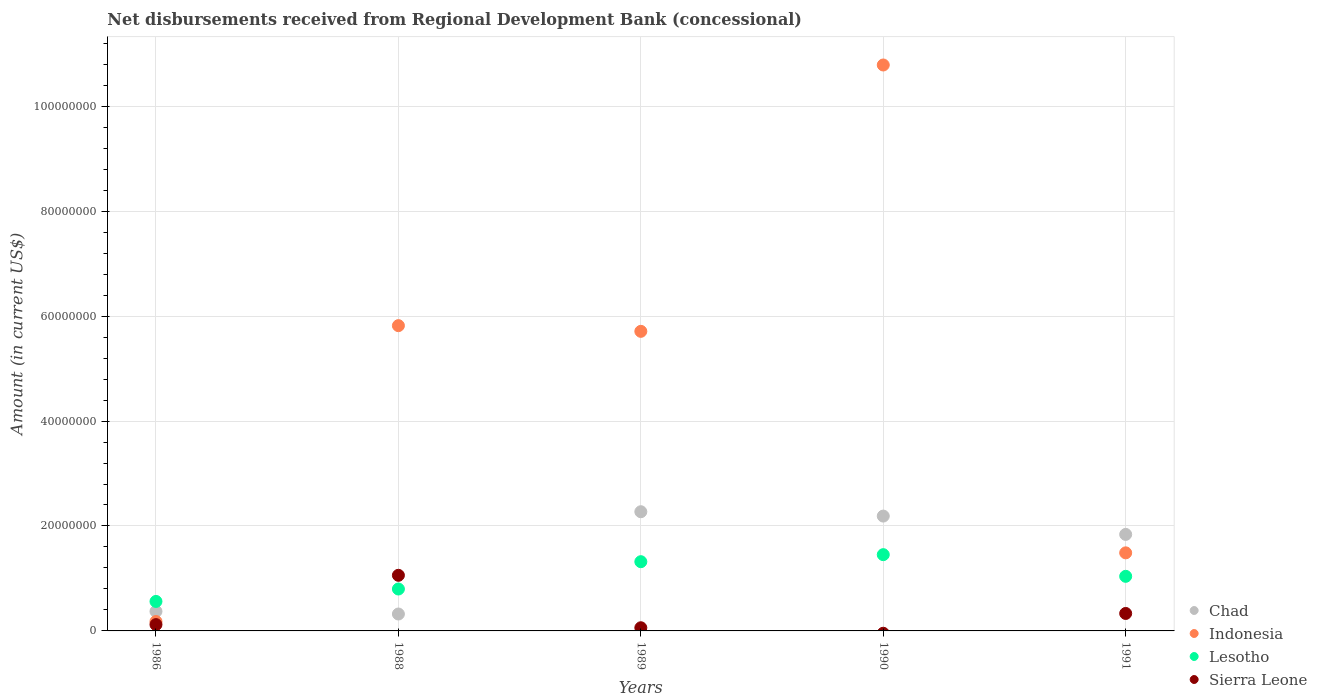What is the amount of disbursements received from Regional Development Bank in Chad in 1989?
Keep it short and to the point. 2.27e+07. Across all years, what is the maximum amount of disbursements received from Regional Development Bank in Sierra Leone?
Your answer should be compact. 1.06e+07. Across all years, what is the minimum amount of disbursements received from Regional Development Bank in Indonesia?
Give a very brief answer. 1.79e+06. In which year was the amount of disbursements received from Regional Development Bank in Sierra Leone maximum?
Your answer should be compact. 1988. What is the total amount of disbursements received from Regional Development Bank in Sierra Leone in the graph?
Your response must be concise. 1.57e+07. What is the difference between the amount of disbursements received from Regional Development Bank in Lesotho in 1986 and that in 1988?
Ensure brevity in your answer.  -2.37e+06. What is the difference between the amount of disbursements received from Regional Development Bank in Lesotho in 1991 and the amount of disbursements received from Regional Development Bank in Sierra Leone in 1989?
Your answer should be compact. 9.80e+06. What is the average amount of disbursements received from Regional Development Bank in Indonesia per year?
Keep it short and to the point. 4.80e+07. In the year 1986, what is the difference between the amount of disbursements received from Regional Development Bank in Indonesia and amount of disbursements received from Regional Development Bank in Sierra Leone?
Make the answer very short. 5.86e+05. What is the ratio of the amount of disbursements received from Regional Development Bank in Lesotho in 1986 to that in 1989?
Offer a terse response. 0.43. Is the amount of disbursements received from Regional Development Bank in Chad in 1988 less than that in 1991?
Your answer should be very brief. Yes. Is the difference between the amount of disbursements received from Regional Development Bank in Indonesia in 1986 and 1988 greater than the difference between the amount of disbursements received from Regional Development Bank in Sierra Leone in 1986 and 1988?
Provide a short and direct response. No. What is the difference between the highest and the second highest amount of disbursements received from Regional Development Bank in Indonesia?
Provide a succinct answer. 4.97e+07. What is the difference between the highest and the lowest amount of disbursements received from Regional Development Bank in Sierra Leone?
Make the answer very short. 1.06e+07. Is it the case that in every year, the sum of the amount of disbursements received from Regional Development Bank in Lesotho and amount of disbursements received from Regional Development Bank in Indonesia  is greater than the sum of amount of disbursements received from Regional Development Bank in Sierra Leone and amount of disbursements received from Regional Development Bank in Chad?
Give a very brief answer. No. Is the amount of disbursements received from Regional Development Bank in Lesotho strictly greater than the amount of disbursements received from Regional Development Bank in Chad over the years?
Your answer should be compact. No. How many dotlines are there?
Provide a short and direct response. 4. How many years are there in the graph?
Provide a succinct answer. 5. What is the difference between two consecutive major ticks on the Y-axis?
Provide a succinct answer. 2.00e+07. Does the graph contain any zero values?
Offer a very short reply. Yes. Does the graph contain grids?
Your response must be concise. Yes. Where does the legend appear in the graph?
Ensure brevity in your answer.  Bottom right. How many legend labels are there?
Your answer should be very brief. 4. How are the legend labels stacked?
Offer a terse response. Vertical. What is the title of the graph?
Your answer should be very brief. Net disbursements received from Regional Development Bank (concessional). Does "Jordan" appear as one of the legend labels in the graph?
Your answer should be very brief. No. What is the label or title of the X-axis?
Your response must be concise. Years. What is the label or title of the Y-axis?
Your answer should be compact. Amount (in current US$). What is the Amount (in current US$) in Chad in 1986?
Provide a short and direct response. 3.72e+06. What is the Amount (in current US$) of Indonesia in 1986?
Your answer should be compact. 1.79e+06. What is the Amount (in current US$) of Lesotho in 1986?
Make the answer very short. 5.62e+06. What is the Amount (in current US$) in Sierra Leone in 1986?
Offer a very short reply. 1.21e+06. What is the Amount (in current US$) in Chad in 1988?
Your answer should be very brief. 3.22e+06. What is the Amount (in current US$) of Indonesia in 1988?
Your answer should be very brief. 5.82e+07. What is the Amount (in current US$) in Lesotho in 1988?
Your response must be concise. 7.99e+06. What is the Amount (in current US$) of Sierra Leone in 1988?
Offer a terse response. 1.06e+07. What is the Amount (in current US$) of Chad in 1989?
Offer a terse response. 2.27e+07. What is the Amount (in current US$) in Indonesia in 1989?
Offer a very short reply. 5.71e+07. What is the Amount (in current US$) of Lesotho in 1989?
Provide a short and direct response. 1.32e+07. What is the Amount (in current US$) in Sierra Leone in 1989?
Your answer should be compact. 6.03e+05. What is the Amount (in current US$) of Chad in 1990?
Your response must be concise. 2.19e+07. What is the Amount (in current US$) of Indonesia in 1990?
Provide a succinct answer. 1.08e+08. What is the Amount (in current US$) of Lesotho in 1990?
Keep it short and to the point. 1.45e+07. What is the Amount (in current US$) in Chad in 1991?
Your response must be concise. 1.84e+07. What is the Amount (in current US$) in Indonesia in 1991?
Give a very brief answer. 1.49e+07. What is the Amount (in current US$) in Lesotho in 1991?
Your answer should be compact. 1.04e+07. What is the Amount (in current US$) of Sierra Leone in 1991?
Provide a short and direct response. 3.33e+06. Across all years, what is the maximum Amount (in current US$) in Chad?
Your answer should be very brief. 2.27e+07. Across all years, what is the maximum Amount (in current US$) in Indonesia?
Give a very brief answer. 1.08e+08. Across all years, what is the maximum Amount (in current US$) of Lesotho?
Your answer should be compact. 1.45e+07. Across all years, what is the maximum Amount (in current US$) in Sierra Leone?
Offer a terse response. 1.06e+07. Across all years, what is the minimum Amount (in current US$) in Chad?
Provide a short and direct response. 3.22e+06. Across all years, what is the minimum Amount (in current US$) in Indonesia?
Give a very brief answer. 1.79e+06. Across all years, what is the minimum Amount (in current US$) in Lesotho?
Give a very brief answer. 5.62e+06. Across all years, what is the minimum Amount (in current US$) in Sierra Leone?
Keep it short and to the point. 0. What is the total Amount (in current US$) in Chad in the graph?
Your response must be concise. 6.99e+07. What is the total Amount (in current US$) in Indonesia in the graph?
Your response must be concise. 2.40e+08. What is the total Amount (in current US$) in Lesotho in the graph?
Provide a short and direct response. 5.17e+07. What is the total Amount (in current US$) in Sierra Leone in the graph?
Ensure brevity in your answer.  1.57e+07. What is the difference between the Amount (in current US$) in Chad in 1986 and that in 1988?
Provide a short and direct response. 4.99e+05. What is the difference between the Amount (in current US$) in Indonesia in 1986 and that in 1988?
Offer a terse response. -5.64e+07. What is the difference between the Amount (in current US$) in Lesotho in 1986 and that in 1988?
Provide a succinct answer. -2.37e+06. What is the difference between the Amount (in current US$) in Sierra Leone in 1986 and that in 1988?
Your response must be concise. -9.39e+06. What is the difference between the Amount (in current US$) in Chad in 1986 and that in 1989?
Your answer should be compact. -1.90e+07. What is the difference between the Amount (in current US$) in Indonesia in 1986 and that in 1989?
Keep it short and to the point. -5.53e+07. What is the difference between the Amount (in current US$) in Lesotho in 1986 and that in 1989?
Provide a short and direct response. -7.57e+06. What is the difference between the Amount (in current US$) in Sierra Leone in 1986 and that in 1989?
Your answer should be very brief. 6.03e+05. What is the difference between the Amount (in current US$) in Chad in 1986 and that in 1990?
Provide a succinct answer. -1.82e+07. What is the difference between the Amount (in current US$) in Indonesia in 1986 and that in 1990?
Provide a succinct answer. -1.06e+08. What is the difference between the Amount (in current US$) in Lesotho in 1986 and that in 1990?
Give a very brief answer. -8.92e+06. What is the difference between the Amount (in current US$) of Chad in 1986 and that in 1991?
Provide a short and direct response. -1.47e+07. What is the difference between the Amount (in current US$) in Indonesia in 1986 and that in 1991?
Your answer should be very brief. -1.31e+07. What is the difference between the Amount (in current US$) in Lesotho in 1986 and that in 1991?
Provide a short and direct response. -4.78e+06. What is the difference between the Amount (in current US$) in Sierra Leone in 1986 and that in 1991?
Your answer should be compact. -2.12e+06. What is the difference between the Amount (in current US$) in Chad in 1988 and that in 1989?
Offer a terse response. -1.95e+07. What is the difference between the Amount (in current US$) in Indonesia in 1988 and that in 1989?
Ensure brevity in your answer.  1.08e+06. What is the difference between the Amount (in current US$) of Lesotho in 1988 and that in 1989?
Your answer should be compact. -5.20e+06. What is the difference between the Amount (in current US$) of Sierra Leone in 1988 and that in 1989?
Offer a very short reply. 1.00e+07. What is the difference between the Amount (in current US$) in Chad in 1988 and that in 1990?
Provide a succinct answer. -1.87e+07. What is the difference between the Amount (in current US$) in Indonesia in 1988 and that in 1990?
Offer a terse response. -4.97e+07. What is the difference between the Amount (in current US$) in Lesotho in 1988 and that in 1990?
Give a very brief answer. -6.55e+06. What is the difference between the Amount (in current US$) in Chad in 1988 and that in 1991?
Keep it short and to the point. -1.52e+07. What is the difference between the Amount (in current US$) of Indonesia in 1988 and that in 1991?
Offer a terse response. 4.33e+07. What is the difference between the Amount (in current US$) of Lesotho in 1988 and that in 1991?
Provide a succinct answer. -2.42e+06. What is the difference between the Amount (in current US$) of Sierra Leone in 1988 and that in 1991?
Your answer should be very brief. 7.27e+06. What is the difference between the Amount (in current US$) of Chad in 1989 and that in 1990?
Provide a succinct answer. 8.29e+05. What is the difference between the Amount (in current US$) of Indonesia in 1989 and that in 1990?
Make the answer very short. -5.08e+07. What is the difference between the Amount (in current US$) in Lesotho in 1989 and that in 1990?
Your response must be concise. -1.34e+06. What is the difference between the Amount (in current US$) of Chad in 1989 and that in 1991?
Provide a succinct answer. 4.32e+06. What is the difference between the Amount (in current US$) of Indonesia in 1989 and that in 1991?
Offer a terse response. 4.22e+07. What is the difference between the Amount (in current US$) in Lesotho in 1989 and that in 1991?
Make the answer very short. 2.79e+06. What is the difference between the Amount (in current US$) of Sierra Leone in 1989 and that in 1991?
Give a very brief answer. -2.73e+06. What is the difference between the Amount (in current US$) in Chad in 1990 and that in 1991?
Give a very brief answer. 3.50e+06. What is the difference between the Amount (in current US$) of Indonesia in 1990 and that in 1991?
Provide a succinct answer. 9.30e+07. What is the difference between the Amount (in current US$) in Lesotho in 1990 and that in 1991?
Your answer should be compact. 4.13e+06. What is the difference between the Amount (in current US$) in Chad in 1986 and the Amount (in current US$) in Indonesia in 1988?
Your answer should be compact. -5.45e+07. What is the difference between the Amount (in current US$) of Chad in 1986 and the Amount (in current US$) of Lesotho in 1988?
Provide a short and direct response. -4.27e+06. What is the difference between the Amount (in current US$) of Chad in 1986 and the Amount (in current US$) of Sierra Leone in 1988?
Your answer should be very brief. -6.88e+06. What is the difference between the Amount (in current US$) in Indonesia in 1986 and the Amount (in current US$) in Lesotho in 1988?
Ensure brevity in your answer.  -6.20e+06. What is the difference between the Amount (in current US$) of Indonesia in 1986 and the Amount (in current US$) of Sierra Leone in 1988?
Ensure brevity in your answer.  -8.81e+06. What is the difference between the Amount (in current US$) in Lesotho in 1986 and the Amount (in current US$) in Sierra Leone in 1988?
Provide a short and direct response. -4.98e+06. What is the difference between the Amount (in current US$) of Chad in 1986 and the Amount (in current US$) of Indonesia in 1989?
Provide a short and direct response. -5.34e+07. What is the difference between the Amount (in current US$) of Chad in 1986 and the Amount (in current US$) of Lesotho in 1989?
Provide a succinct answer. -9.47e+06. What is the difference between the Amount (in current US$) in Chad in 1986 and the Amount (in current US$) in Sierra Leone in 1989?
Provide a short and direct response. 3.12e+06. What is the difference between the Amount (in current US$) in Indonesia in 1986 and the Amount (in current US$) in Lesotho in 1989?
Provide a short and direct response. -1.14e+07. What is the difference between the Amount (in current US$) of Indonesia in 1986 and the Amount (in current US$) of Sierra Leone in 1989?
Ensure brevity in your answer.  1.19e+06. What is the difference between the Amount (in current US$) in Lesotho in 1986 and the Amount (in current US$) in Sierra Leone in 1989?
Make the answer very short. 5.02e+06. What is the difference between the Amount (in current US$) of Chad in 1986 and the Amount (in current US$) of Indonesia in 1990?
Your answer should be compact. -1.04e+08. What is the difference between the Amount (in current US$) of Chad in 1986 and the Amount (in current US$) of Lesotho in 1990?
Offer a very short reply. -1.08e+07. What is the difference between the Amount (in current US$) in Indonesia in 1986 and the Amount (in current US$) in Lesotho in 1990?
Provide a succinct answer. -1.27e+07. What is the difference between the Amount (in current US$) of Chad in 1986 and the Amount (in current US$) of Indonesia in 1991?
Make the answer very short. -1.12e+07. What is the difference between the Amount (in current US$) in Chad in 1986 and the Amount (in current US$) in Lesotho in 1991?
Keep it short and to the point. -6.68e+06. What is the difference between the Amount (in current US$) of Chad in 1986 and the Amount (in current US$) of Sierra Leone in 1991?
Offer a terse response. 3.93e+05. What is the difference between the Amount (in current US$) in Indonesia in 1986 and the Amount (in current US$) in Lesotho in 1991?
Offer a terse response. -8.61e+06. What is the difference between the Amount (in current US$) in Indonesia in 1986 and the Amount (in current US$) in Sierra Leone in 1991?
Offer a very short reply. -1.54e+06. What is the difference between the Amount (in current US$) in Lesotho in 1986 and the Amount (in current US$) in Sierra Leone in 1991?
Offer a terse response. 2.29e+06. What is the difference between the Amount (in current US$) of Chad in 1988 and the Amount (in current US$) of Indonesia in 1989?
Offer a terse response. -5.39e+07. What is the difference between the Amount (in current US$) of Chad in 1988 and the Amount (in current US$) of Lesotho in 1989?
Give a very brief answer. -9.97e+06. What is the difference between the Amount (in current US$) of Chad in 1988 and the Amount (in current US$) of Sierra Leone in 1989?
Make the answer very short. 2.62e+06. What is the difference between the Amount (in current US$) of Indonesia in 1988 and the Amount (in current US$) of Lesotho in 1989?
Keep it short and to the point. 4.50e+07. What is the difference between the Amount (in current US$) of Indonesia in 1988 and the Amount (in current US$) of Sierra Leone in 1989?
Offer a terse response. 5.76e+07. What is the difference between the Amount (in current US$) in Lesotho in 1988 and the Amount (in current US$) in Sierra Leone in 1989?
Keep it short and to the point. 7.39e+06. What is the difference between the Amount (in current US$) in Chad in 1988 and the Amount (in current US$) in Indonesia in 1990?
Make the answer very short. -1.05e+08. What is the difference between the Amount (in current US$) in Chad in 1988 and the Amount (in current US$) in Lesotho in 1990?
Offer a very short reply. -1.13e+07. What is the difference between the Amount (in current US$) of Indonesia in 1988 and the Amount (in current US$) of Lesotho in 1990?
Provide a short and direct response. 4.36e+07. What is the difference between the Amount (in current US$) of Chad in 1988 and the Amount (in current US$) of Indonesia in 1991?
Keep it short and to the point. -1.17e+07. What is the difference between the Amount (in current US$) in Chad in 1988 and the Amount (in current US$) in Lesotho in 1991?
Give a very brief answer. -7.18e+06. What is the difference between the Amount (in current US$) of Chad in 1988 and the Amount (in current US$) of Sierra Leone in 1991?
Offer a terse response. -1.06e+05. What is the difference between the Amount (in current US$) in Indonesia in 1988 and the Amount (in current US$) in Lesotho in 1991?
Give a very brief answer. 4.78e+07. What is the difference between the Amount (in current US$) in Indonesia in 1988 and the Amount (in current US$) in Sierra Leone in 1991?
Provide a short and direct response. 5.49e+07. What is the difference between the Amount (in current US$) in Lesotho in 1988 and the Amount (in current US$) in Sierra Leone in 1991?
Provide a succinct answer. 4.66e+06. What is the difference between the Amount (in current US$) of Chad in 1989 and the Amount (in current US$) of Indonesia in 1990?
Give a very brief answer. -8.51e+07. What is the difference between the Amount (in current US$) in Chad in 1989 and the Amount (in current US$) in Lesotho in 1990?
Your answer should be very brief. 8.18e+06. What is the difference between the Amount (in current US$) in Indonesia in 1989 and the Amount (in current US$) in Lesotho in 1990?
Ensure brevity in your answer.  4.26e+07. What is the difference between the Amount (in current US$) in Chad in 1989 and the Amount (in current US$) in Indonesia in 1991?
Make the answer very short. 7.84e+06. What is the difference between the Amount (in current US$) of Chad in 1989 and the Amount (in current US$) of Lesotho in 1991?
Offer a terse response. 1.23e+07. What is the difference between the Amount (in current US$) of Chad in 1989 and the Amount (in current US$) of Sierra Leone in 1991?
Provide a short and direct response. 1.94e+07. What is the difference between the Amount (in current US$) in Indonesia in 1989 and the Amount (in current US$) in Lesotho in 1991?
Give a very brief answer. 4.67e+07. What is the difference between the Amount (in current US$) in Indonesia in 1989 and the Amount (in current US$) in Sierra Leone in 1991?
Ensure brevity in your answer.  5.38e+07. What is the difference between the Amount (in current US$) in Lesotho in 1989 and the Amount (in current US$) in Sierra Leone in 1991?
Your answer should be compact. 9.86e+06. What is the difference between the Amount (in current US$) of Chad in 1990 and the Amount (in current US$) of Indonesia in 1991?
Provide a short and direct response. 7.01e+06. What is the difference between the Amount (in current US$) in Chad in 1990 and the Amount (in current US$) in Lesotho in 1991?
Give a very brief answer. 1.15e+07. What is the difference between the Amount (in current US$) in Chad in 1990 and the Amount (in current US$) in Sierra Leone in 1991?
Offer a terse response. 1.86e+07. What is the difference between the Amount (in current US$) of Indonesia in 1990 and the Amount (in current US$) of Lesotho in 1991?
Provide a short and direct response. 9.75e+07. What is the difference between the Amount (in current US$) in Indonesia in 1990 and the Amount (in current US$) in Sierra Leone in 1991?
Provide a short and direct response. 1.05e+08. What is the difference between the Amount (in current US$) in Lesotho in 1990 and the Amount (in current US$) in Sierra Leone in 1991?
Make the answer very short. 1.12e+07. What is the average Amount (in current US$) in Chad per year?
Provide a succinct answer. 1.40e+07. What is the average Amount (in current US$) of Indonesia per year?
Your answer should be very brief. 4.80e+07. What is the average Amount (in current US$) in Lesotho per year?
Your answer should be compact. 1.03e+07. What is the average Amount (in current US$) in Sierra Leone per year?
Offer a terse response. 3.15e+06. In the year 1986, what is the difference between the Amount (in current US$) of Chad and Amount (in current US$) of Indonesia?
Your answer should be very brief. 1.93e+06. In the year 1986, what is the difference between the Amount (in current US$) of Chad and Amount (in current US$) of Lesotho?
Give a very brief answer. -1.90e+06. In the year 1986, what is the difference between the Amount (in current US$) of Chad and Amount (in current US$) of Sierra Leone?
Ensure brevity in your answer.  2.52e+06. In the year 1986, what is the difference between the Amount (in current US$) in Indonesia and Amount (in current US$) in Lesotho?
Provide a short and direct response. -3.83e+06. In the year 1986, what is the difference between the Amount (in current US$) of Indonesia and Amount (in current US$) of Sierra Leone?
Your answer should be compact. 5.86e+05. In the year 1986, what is the difference between the Amount (in current US$) of Lesotho and Amount (in current US$) of Sierra Leone?
Your response must be concise. 4.41e+06. In the year 1988, what is the difference between the Amount (in current US$) in Chad and Amount (in current US$) in Indonesia?
Provide a succinct answer. -5.50e+07. In the year 1988, what is the difference between the Amount (in current US$) in Chad and Amount (in current US$) in Lesotho?
Offer a terse response. -4.77e+06. In the year 1988, what is the difference between the Amount (in current US$) in Chad and Amount (in current US$) in Sierra Leone?
Offer a very short reply. -7.38e+06. In the year 1988, what is the difference between the Amount (in current US$) of Indonesia and Amount (in current US$) of Lesotho?
Your answer should be compact. 5.02e+07. In the year 1988, what is the difference between the Amount (in current US$) of Indonesia and Amount (in current US$) of Sierra Leone?
Offer a very short reply. 4.76e+07. In the year 1988, what is the difference between the Amount (in current US$) in Lesotho and Amount (in current US$) in Sierra Leone?
Provide a short and direct response. -2.61e+06. In the year 1989, what is the difference between the Amount (in current US$) in Chad and Amount (in current US$) in Indonesia?
Give a very brief answer. -3.44e+07. In the year 1989, what is the difference between the Amount (in current US$) of Chad and Amount (in current US$) of Lesotho?
Offer a terse response. 9.52e+06. In the year 1989, what is the difference between the Amount (in current US$) in Chad and Amount (in current US$) in Sierra Leone?
Your response must be concise. 2.21e+07. In the year 1989, what is the difference between the Amount (in current US$) in Indonesia and Amount (in current US$) in Lesotho?
Provide a short and direct response. 4.39e+07. In the year 1989, what is the difference between the Amount (in current US$) in Indonesia and Amount (in current US$) in Sierra Leone?
Your response must be concise. 5.65e+07. In the year 1989, what is the difference between the Amount (in current US$) in Lesotho and Amount (in current US$) in Sierra Leone?
Make the answer very short. 1.26e+07. In the year 1990, what is the difference between the Amount (in current US$) in Chad and Amount (in current US$) in Indonesia?
Give a very brief answer. -8.60e+07. In the year 1990, what is the difference between the Amount (in current US$) of Chad and Amount (in current US$) of Lesotho?
Offer a very short reply. 7.35e+06. In the year 1990, what is the difference between the Amount (in current US$) in Indonesia and Amount (in current US$) in Lesotho?
Ensure brevity in your answer.  9.33e+07. In the year 1991, what is the difference between the Amount (in current US$) of Chad and Amount (in current US$) of Indonesia?
Your answer should be very brief. 3.51e+06. In the year 1991, what is the difference between the Amount (in current US$) in Chad and Amount (in current US$) in Lesotho?
Provide a succinct answer. 7.99e+06. In the year 1991, what is the difference between the Amount (in current US$) of Chad and Amount (in current US$) of Sierra Leone?
Give a very brief answer. 1.51e+07. In the year 1991, what is the difference between the Amount (in current US$) in Indonesia and Amount (in current US$) in Lesotho?
Provide a succinct answer. 4.48e+06. In the year 1991, what is the difference between the Amount (in current US$) in Indonesia and Amount (in current US$) in Sierra Leone?
Keep it short and to the point. 1.16e+07. In the year 1991, what is the difference between the Amount (in current US$) in Lesotho and Amount (in current US$) in Sierra Leone?
Offer a terse response. 7.08e+06. What is the ratio of the Amount (in current US$) in Chad in 1986 to that in 1988?
Your response must be concise. 1.15. What is the ratio of the Amount (in current US$) of Indonesia in 1986 to that in 1988?
Give a very brief answer. 0.03. What is the ratio of the Amount (in current US$) in Lesotho in 1986 to that in 1988?
Make the answer very short. 0.7. What is the ratio of the Amount (in current US$) of Sierra Leone in 1986 to that in 1988?
Keep it short and to the point. 0.11. What is the ratio of the Amount (in current US$) in Chad in 1986 to that in 1989?
Provide a short and direct response. 0.16. What is the ratio of the Amount (in current US$) in Indonesia in 1986 to that in 1989?
Provide a short and direct response. 0.03. What is the ratio of the Amount (in current US$) in Lesotho in 1986 to that in 1989?
Provide a succinct answer. 0.43. What is the ratio of the Amount (in current US$) in Sierra Leone in 1986 to that in 1989?
Your response must be concise. 2. What is the ratio of the Amount (in current US$) of Chad in 1986 to that in 1990?
Your answer should be very brief. 0.17. What is the ratio of the Amount (in current US$) in Indonesia in 1986 to that in 1990?
Offer a very short reply. 0.02. What is the ratio of the Amount (in current US$) of Lesotho in 1986 to that in 1990?
Your response must be concise. 0.39. What is the ratio of the Amount (in current US$) in Chad in 1986 to that in 1991?
Your response must be concise. 0.2. What is the ratio of the Amount (in current US$) in Indonesia in 1986 to that in 1991?
Make the answer very short. 0.12. What is the ratio of the Amount (in current US$) in Lesotho in 1986 to that in 1991?
Offer a very short reply. 0.54. What is the ratio of the Amount (in current US$) in Sierra Leone in 1986 to that in 1991?
Your answer should be compact. 0.36. What is the ratio of the Amount (in current US$) of Chad in 1988 to that in 1989?
Make the answer very short. 0.14. What is the ratio of the Amount (in current US$) in Lesotho in 1988 to that in 1989?
Make the answer very short. 0.61. What is the ratio of the Amount (in current US$) of Sierra Leone in 1988 to that in 1989?
Provide a short and direct response. 17.58. What is the ratio of the Amount (in current US$) in Chad in 1988 to that in 1990?
Your answer should be compact. 0.15. What is the ratio of the Amount (in current US$) of Indonesia in 1988 to that in 1990?
Keep it short and to the point. 0.54. What is the ratio of the Amount (in current US$) of Lesotho in 1988 to that in 1990?
Offer a very short reply. 0.55. What is the ratio of the Amount (in current US$) of Chad in 1988 to that in 1991?
Provide a short and direct response. 0.18. What is the ratio of the Amount (in current US$) of Indonesia in 1988 to that in 1991?
Provide a short and direct response. 3.91. What is the ratio of the Amount (in current US$) in Lesotho in 1988 to that in 1991?
Your answer should be compact. 0.77. What is the ratio of the Amount (in current US$) in Sierra Leone in 1988 to that in 1991?
Offer a terse response. 3.18. What is the ratio of the Amount (in current US$) in Chad in 1989 to that in 1990?
Your response must be concise. 1.04. What is the ratio of the Amount (in current US$) in Indonesia in 1989 to that in 1990?
Ensure brevity in your answer.  0.53. What is the ratio of the Amount (in current US$) in Lesotho in 1989 to that in 1990?
Offer a very short reply. 0.91. What is the ratio of the Amount (in current US$) in Chad in 1989 to that in 1991?
Your answer should be very brief. 1.24. What is the ratio of the Amount (in current US$) of Indonesia in 1989 to that in 1991?
Keep it short and to the point. 3.84. What is the ratio of the Amount (in current US$) of Lesotho in 1989 to that in 1991?
Your answer should be compact. 1.27. What is the ratio of the Amount (in current US$) in Sierra Leone in 1989 to that in 1991?
Provide a short and direct response. 0.18. What is the ratio of the Amount (in current US$) in Chad in 1990 to that in 1991?
Your answer should be very brief. 1.19. What is the ratio of the Amount (in current US$) of Indonesia in 1990 to that in 1991?
Provide a succinct answer. 7.25. What is the ratio of the Amount (in current US$) in Lesotho in 1990 to that in 1991?
Provide a succinct answer. 1.4. What is the difference between the highest and the second highest Amount (in current US$) in Chad?
Provide a succinct answer. 8.29e+05. What is the difference between the highest and the second highest Amount (in current US$) of Indonesia?
Your answer should be compact. 4.97e+07. What is the difference between the highest and the second highest Amount (in current US$) in Lesotho?
Your answer should be compact. 1.34e+06. What is the difference between the highest and the second highest Amount (in current US$) in Sierra Leone?
Your response must be concise. 7.27e+06. What is the difference between the highest and the lowest Amount (in current US$) of Chad?
Your answer should be compact. 1.95e+07. What is the difference between the highest and the lowest Amount (in current US$) of Indonesia?
Provide a short and direct response. 1.06e+08. What is the difference between the highest and the lowest Amount (in current US$) of Lesotho?
Provide a short and direct response. 8.92e+06. What is the difference between the highest and the lowest Amount (in current US$) in Sierra Leone?
Your answer should be compact. 1.06e+07. 